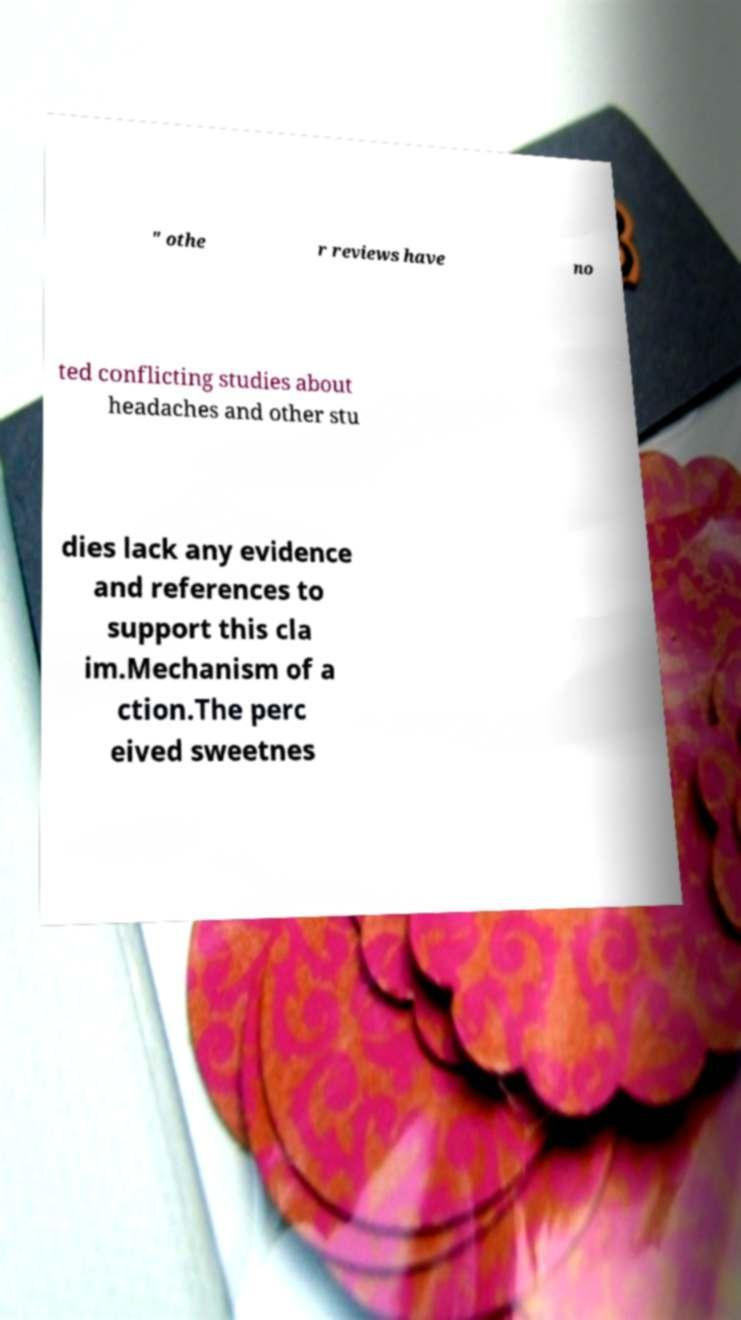I need the written content from this picture converted into text. Can you do that? " othe r reviews have no ted conflicting studies about headaches and other stu dies lack any evidence and references to support this cla im.Mechanism of a ction.The perc eived sweetnes 